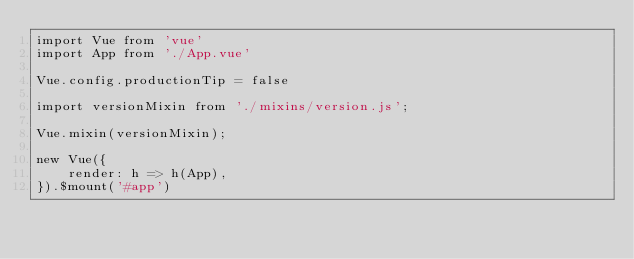<code> <loc_0><loc_0><loc_500><loc_500><_JavaScript_>import Vue from 'vue'
import App from './App.vue'

Vue.config.productionTip = false

import versionMixin from './mixins/version.js';

Vue.mixin(versionMixin);

new Vue({
    render: h => h(App),
}).$mount('#app')
</code> 